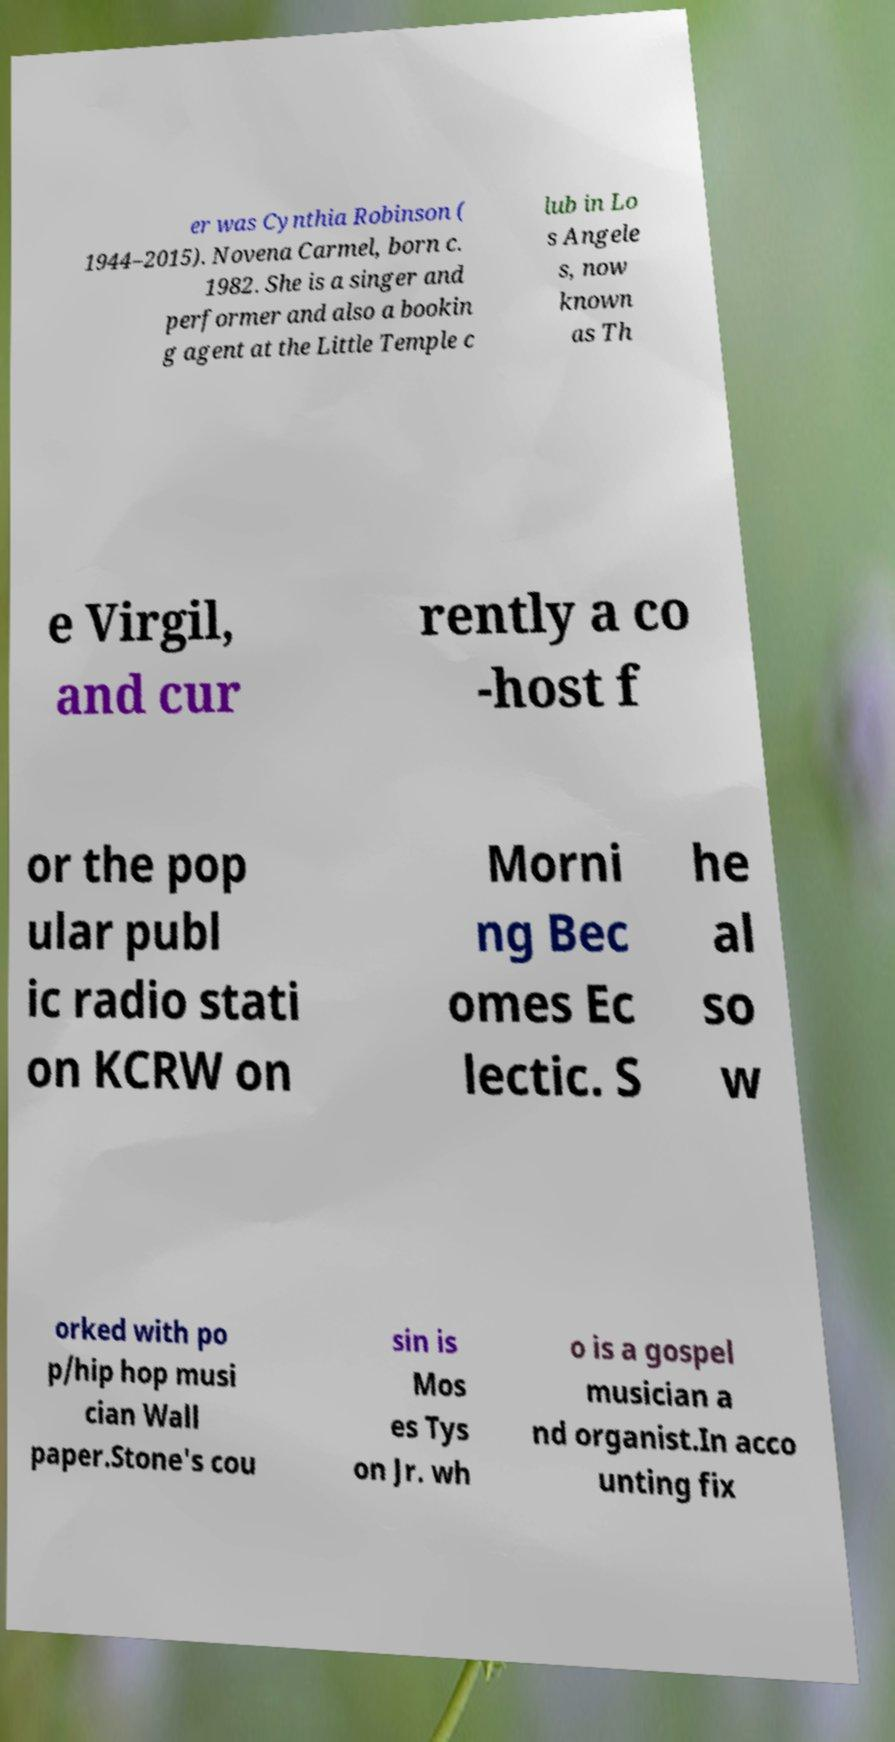For documentation purposes, I need the text within this image transcribed. Could you provide that? er was Cynthia Robinson ( 1944–2015). Novena Carmel, born c. 1982. She is a singer and performer and also a bookin g agent at the Little Temple c lub in Lo s Angele s, now known as Th e Virgil, and cur rently a co -host f or the pop ular publ ic radio stati on KCRW on Morni ng Bec omes Ec lectic. S he al so w orked with po p/hip hop musi cian Wall paper.Stone's cou sin is Mos es Tys on Jr. wh o is a gospel musician a nd organist.In acco unting fix 